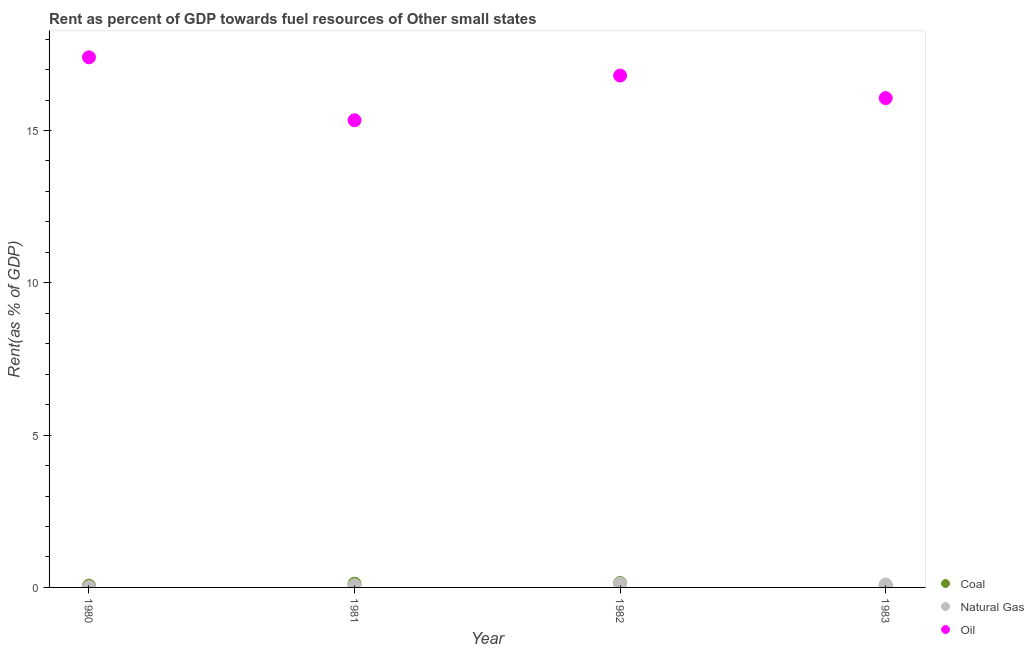Is the number of dotlines equal to the number of legend labels?
Your answer should be very brief. Yes. What is the rent towards natural gas in 1983?
Keep it short and to the point. 0.09. Across all years, what is the maximum rent towards coal?
Ensure brevity in your answer.  0.15. Across all years, what is the minimum rent towards coal?
Keep it short and to the point. 0.05. What is the total rent towards coal in the graph?
Your answer should be very brief. 0.38. What is the difference between the rent towards natural gas in 1981 and that in 1983?
Ensure brevity in your answer.  -0.02. What is the difference between the rent towards coal in 1981 and the rent towards natural gas in 1983?
Give a very brief answer. 0.03. What is the average rent towards natural gas per year?
Your answer should be very brief. 0.08. In the year 1982, what is the difference between the rent towards coal and rent towards oil?
Give a very brief answer. -16.66. In how many years, is the rent towards coal greater than 3 %?
Provide a succinct answer. 0. What is the ratio of the rent towards coal in 1980 to that in 1983?
Provide a succinct answer. 1.05. Is the rent towards coal in 1980 less than that in 1983?
Your answer should be compact. No. What is the difference between the highest and the second highest rent towards oil?
Make the answer very short. 0.6. What is the difference between the highest and the lowest rent towards oil?
Give a very brief answer. 2.07. In how many years, is the rent towards coal greater than the average rent towards coal taken over all years?
Offer a very short reply. 2. Is it the case that in every year, the sum of the rent towards coal and rent towards natural gas is greater than the rent towards oil?
Offer a terse response. No. Does the rent towards natural gas monotonically increase over the years?
Offer a terse response. No. How many dotlines are there?
Ensure brevity in your answer.  3. What is the title of the graph?
Keep it short and to the point. Rent as percent of GDP towards fuel resources of Other small states. What is the label or title of the X-axis?
Provide a short and direct response. Year. What is the label or title of the Y-axis?
Offer a terse response. Rent(as % of GDP). What is the Rent(as % of GDP) of Coal in 1980?
Give a very brief answer. 0.06. What is the Rent(as % of GDP) in Natural Gas in 1980?
Provide a succinct answer. 0.01. What is the Rent(as % of GDP) of Oil in 1980?
Your answer should be compact. 17.4. What is the Rent(as % of GDP) of Coal in 1981?
Give a very brief answer. 0.12. What is the Rent(as % of GDP) of Natural Gas in 1981?
Provide a short and direct response. 0.07. What is the Rent(as % of GDP) in Oil in 1981?
Your answer should be very brief. 15.34. What is the Rent(as % of GDP) of Coal in 1982?
Keep it short and to the point. 0.15. What is the Rent(as % of GDP) of Natural Gas in 1982?
Give a very brief answer. 0.13. What is the Rent(as % of GDP) in Oil in 1982?
Give a very brief answer. 16.8. What is the Rent(as % of GDP) in Coal in 1983?
Provide a succinct answer. 0.05. What is the Rent(as % of GDP) of Natural Gas in 1983?
Your response must be concise. 0.09. What is the Rent(as % of GDP) in Oil in 1983?
Offer a very short reply. 16.06. Across all years, what is the maximum Rent(as % of GDP) of Coal?
Your answer should be very brief. 0.15. Across all years, what is the maximum Rent(as % of GDP) of Natural Gas?
Provide a succinct answer. 0.13. Across all years, what is the maximum Rent(as % of GDP) of Oil?
Make the answer very short. 17.4. Across all years, what is the minimum Rent(as % of GDP) of Coal?
Offer a terse response. 0.05. Across all years, what is the minimum Rent(as % of GDP) in Natural Gas?
Make the answer very short. 0.01. Across all years, what is the minimum Rent(as % of GDP) of Oil?
Keep it short and to the point. 15.34. What is the total Rent(as % of GDP) of Coal in the graph?
Your answer should be compact. 0.38. What is the total Rent(as % of GDP) of Natural Gas in the graph?
Your response must be concise. 0.31. What is the total Rent(as % of GDP) in Oil in the graph?
Provide a short and direct response. 65.61. What is the difference between the Rent(as % of GDP) of Coal in 1980 and that in 1981?
Give a very brief answer. -0.06. What is the difference between the Rent(as % of GDP) of Natural Gas in 1980 and that in 1981?
Provide a short and direct response. -0.06. What is the difference between the Rent(as % of GDP) in Oil in 1980 and that in 1981?
Your response must be concise. 2.07. What is the difference between the Rent(as % of GDP) of Coal in 1980 and that in 1982?
Your answer should be very brief. -0.09. What is the difference between the Rent(as % of GDP) of Natural Gas in 1980 and that in 1982?
Make the answer very short. -0.11. What is the difference between the Rent(as % of GDP) of Oil in 1980 and that in 1982?
Provide a succinct answer. 0.6. What is the difference between the Rent(as % of GDP) in Coal in 1980 and that in 1983?
Your response must be concise. 0. What is the difference between the Rent(as % of GDP) of Natural Gas in 1980 and that in 1983?
Offer a very short reply. -0.08. What is the difference between the Rent(as % of GDP) in Oil in 1980 and that in 1983?
Offer a terse response. 1.34. What is the difference between the Rent(as % of GDP) in Coal in 1981 and that in 1982?
Give a very brief answer. -0.03. What is the difference between the Rent(as % of GDP) of Natural Gas in 1981 and that in 1982?
Offer a very short reply. -0.05. What is the difference between the Rent(as % of GDP) in Oil in 1981 and that in 1982?
Give a very brief answer. -1.47. What is the difference between the Rent(as % of GDP) of Coal in 1981 and that in 1983?
Provide a succinct answer. 0.07. What is the difference between the Rent(as % of GDP) in Natural Gas in 1981 and that in 1983?
Offer a terse response. -0.02. What is the difference between the Rent(as % of GDP) of Oil in 1981 and that in 1983?
Keep it short and to the point. -0.73. What is the difference between the Rent(as % of GDP) in Coal in 1982 and that in 1983?
Make the answer very short. 0.09. What is the difference between the Rent(as % of GDP) of Natural Gas in 1982 and that in 1983?
Offer a very short reply. 0.03. What is the difference between the Rent(as % of GDP) in Oil in 1982 and that in 1983?
Your answer should be very brief. 0.74. What is the difference between the Rent(as % of GDP) in Coal in 1980 and the Rent(as % of GDP) in Natural Gas in 1981?
Offer a terse response. -0.01. What is the difference between the Rent(as % of GDP) in Coal in 1980 and the Rent(as % of GDP) in Oil in 1981?
Offer a very short reply. -15.28. What is the difference between the Rent(as % of GDP) in Natural Gas in 1980 and the Rent(as % of GDP) in Oil in 1981?
Offer a terse response. -15.32. What is the difference between the Rent(as % of GDP) in Coal in 1980 and the Rent(as % of GDP) in Natural Gas in 1982?
Your answer should be very brief. -0.07. What is the difference between the Rent(as % of GDP) of Coal in 1980 and the Rent(as % of GDP) of Oil in 1982?
Give a very brief answer. -16.75. What is the difference between the Rent(as % of GDP) of Natural Gas in 1980 and the Rent(as % of GDP) of Oil in 1982?
Your answer should be very brief. -16.79. What is the difference between the Rent(as % of GDP) of Coal in 1980 and the Rent(as % of GDP) of Natural Gas in 1983?
Provide a short and direct response. -0.04. What is the difference between the Rent(as % of GDP) in Coal in 1980 and the Rent(as % of GDP) in Oil in 1983?
Make the answer very short. -16.01. What is the difference between the Rent(as % of GDP) of Natural Gas in 1980 and the Rent(as % of GDP) of Oil in 1983?
Provide a short and direct response. -16.05. What is the difference between the Rent(as % of GDP) in Coal in 1981 and the Rent(as % of GDP) in Natural Gas in 1982?
Provide a short and direct response. -0.01. What is the difference between the Rent(as % of GDP) of Coal in 1981 and the Rent(as % of GDP) of Oil in 1982?
Your response must be concise. -16.68. What is the difference between the Rent(as % of GDP) in Natural Gas in 1981 and the Rent(as % of GDP) in Oil in 1982?
Provide a succinct answer. -16.73. What is the difference between the Rent(as % of GDP) in Coal in 1981 and the Rent(as % of GDP) in Natural Gas in 1983?
Your answer should be very brief. 0.03. What is the difference between the Rent(as % of GDP) in Coal in 1981 and the Rent(as % of GDP) in Oil in 1983?
Your response must be concise. -15.94. What is the difference between the Rent(as % of GDP) of Natural Gas in 1981 and the Rent(as % of GDP) of Oil in 1983?
Keep it short and to the point. -15.99. What is the difference between the Rent(as % of GDP) in Coal in 1982 and the Rent(as % of GDP) in Natural Gas in 1983?
Offer a terse response. 0.05. What is the difference between the Rent(as % of GDP) of Coal in 1982 and the Rent(as % of GDP) of Oil in 1983?
Your response must be concise. -15.92. What is the difference between the Rent(as % of GDP) of Natural Gas in 1982 and the Rent(as % of GDP) of Oil in 1983?
Ensure brevity in your answer.  -15.94. What is the average Rent(as % of GDP) in Coal per year?
Offer a very short reply. 0.1. What is the average Rent(as % of GDP) of Natural Gas per year?
Provide a short and direct response. 0.08. What is the average Rent(as % of GDP) in Oil per year?
Make the answer very short. 16.4. In the year 1980, what is the difference between the Rent(as % of GDP) in Coal and Rent(as % of GDP) in Natural Gas?
Ensure brevity in your answer.  0.04. In the year 1980, what is the difference between the Rent(as % of GDP) in Coal and Rent(as % of GDP) in Oil?
Offer a very short reply. -17.35. In the year 1980, what is the difference between the Rent(as % of GDP) in Natural Gas and Rent(as % of GDP) in Oil?
Give a very brief answer. -17.39. In the year 1981, what is the difference between the Rent(as % of GDP) in Coal and Rent(as % of GDP) in Natural Gas?
Provide a succinct answer. 0.05. In the year 1981, what is the difference between the Rent(as % of GDP) in Coal and Rent(as % of GDP) in Oil?
Give a very brief answer. -15.22. In the year 1981, what is the difference between the Rent(as % of GDP) in Natural Gas and Rent(as % of GDP) in Oil?
Ensure brevity in your answer.  -15.27. In the year 1982, what is the difference between the Rent(as % of GDP) of Coal and Rent(as % of GDP) of Natural Gas?
Offer a very short reply. 0.02. In the year 1982, what is the difference between the Rent(as % of GDP) of Coal and Rent(as % of GDP) of Oil?
Give a very brief answer. -16.66. In the year 1982, what is the difference between the Rent(as % of GDP) of Natural Gas and Rent(as % of GDP) of Oil?
Keep it short and to the point. -16.68. In the year 1983, what is the difference between the Rent(as % of GDP) of Coal and Rent(as % of GDP) of Natural Gas?
Make the answer very short. -0.04. In the year 1983, what is the difference between the Rent(as % of GDP) of Coal and Rent(as % of GDP) of Oil?
Give a very brief answer. -16.01. In the year 1983, what is the difference between the Rent(as % of GDP) of Natural Gas and Rent(as % of GDP) of Oil?
Your answer should be very brief. -15.97. What is the ratio of the Rent(as % of GDP) in Coal in 1980 to that in 1981?
Make the answer very short. 0.48. What is the ratio of the Rent(as % of GDP) in Natural Gas in 1980 to that in 1981?
Your response must be concise. 0.18. What is the ratio of the Rent(as % of GDP) in Oil in 1980 to that in 1981?
Your response must be concise. 1.13. What is the ratio of the Rent(as % of GDP) of Coal in 1980 to that in 1982?
Offer a very short reply. 0.39. What is the ratio of the Rent(as % of GDP) of Natural Gas in 1980 to that in 1982?
Your answer should be compact. 0.1. What is the ratio of the Rent(as % of GDP) in Oil in 1980 to that in 1982?
Offer a very short reply. 1.04. What is the ratio of the Rent(as % of GDP) of Coal in 1980 to that in 1983?
Provide a succinct answer. 1.05. What is the ratio of the Rent(as % of GDP) in Natural Gas in 1980 to that in 1983?
Provide a succinct answer. 0.14. What is the ratio of the Rent(as % of GDP) in Oil in 1980 to that in 1983?
Keep it short and to the point. 1.08. What is the ratio of the Rent(as % of GDP) in Coal in 1981 to that in 1982?
Make the answer very short. 0.83. What is the ratio of the Rent(as % of GDP) in Natural Gas in 1981 to that in 1982?
Provide a short and direct response. 0.57. What is the ratio of the Rent(as % of GDP) in Oil in 1981 to that in 1982?
Your response must be concise. 0.91. What is the ratio of the Rent(as % of GDP) in Coal in 1981 to that in 1983?
Your response must be concise. 2.21. What is the ratio of the Rent(as % of GDP) of Natural Gas in 1981 to that in 1983?
Provide a succinct answer. 0.77. What is the ratio of the Rent(as % of GDP) of Oil in 1981 to that in 1983?
Give a very brief answer. 0.95. What is the ratio of the Rent(as % of GDP) of Coal in 1982 to that in 1983?
Your response must be concise. 2.68. What is the ratio of the Rent(as % of GDP) of Natural Gas in 1982 to that in 1983?
Offer a very short reply. 1.35. What is the ratio of the Rent(as % of GDP) in Oil in 1982 to that in 1983?
Provide a succinct answer. 1.05. What is the difference between the highest and the second highest Rent(as % of GDP) in Coal?
Keep it short and to the point. 0.03. What is the difference between the highest and the second highest Rent(as % of GDP) of Natural Gas?
Offer a very short reply. 0.03. What is the difference between the highest and the second highest Rent(as % of GDP) in Oil?
Your answer should be compact. 0.6. What is the difference between the highest and the lowest Rent(as % of GDP) in Coal?
Your answer should be compact. 0.09. What is the difference between the highest and the lowest Rent(as % of GDP) in Natural Gas?
Ensure brevity in your answer.  0.11. What is the difference between the highest and the lowest Rent(as % of GDP) of Oil?
Ensure brevity in your answer.  2.07. 